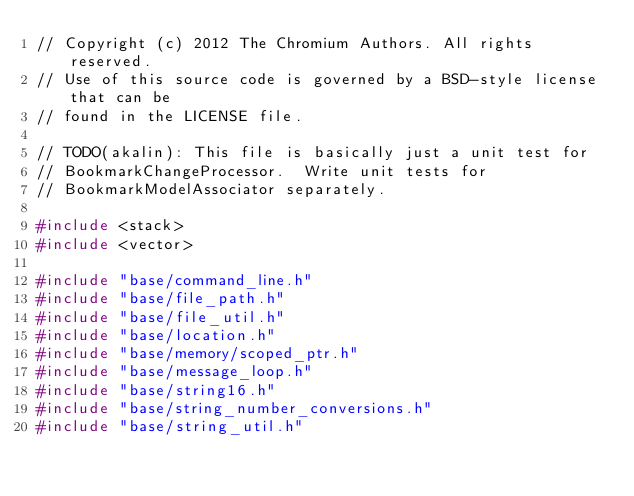Convert code to text. <code><loc_0><loc_0><loc_500><loc_500><_C++_>// Copyright (c) 2012 The Chromium Authors. All rights reserved.
// Use of this source code is governed by a BSD-style license that can be
// found in the LICENSE file.

// TODO(akalin): This file is basically just a unit test for
// BookmarkChangeProcessor.  Write unit tests for
// BookmarkModelAssociator separately.

#include <stack>
#include <vector>

#include "base/command_line.h"
#include "base/file_path.h"
#include "base/file_util.h"
#include "base/location.h"
#include "base/memory/scoped_ptr.h"
#include "base/message_loop.h"
#include "base/string16.h"
#include "base/string_number_conversions.h"
#include "base/string_util.h"</code> 